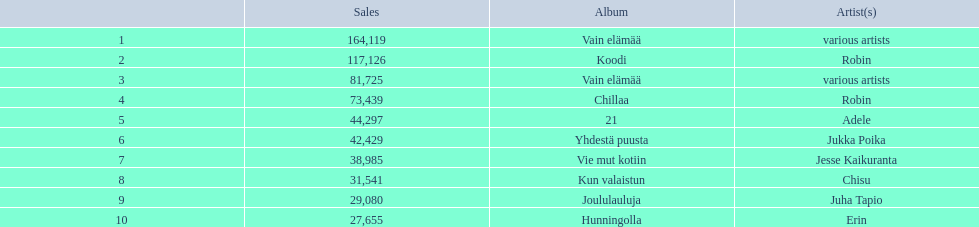Can you give me this table in json format? {'header': ['', 'Sales', 'Album', 'Artist(s)'], 'rows': [['1', '164,119', 'Vain elämää', 'various artists'], ['2', '117,126', 'Koodi', 'Robin'], ['3', '81,725', 'Vain elämää', 'various artists'], ['4', '73,439', 'Chillaa', 'Robin'], ['5', '44,297', '21', 'Adele'], ['6', '42,429', 'Yhdestä puusta', 'Jukka Poika'], ['7', '38,985', 'Vie mut kotiin', 'Jesse Kaikuranta'], ['8', '31,541', 'Kun valaistun', 'Chisu'], ['9', '29,080', 'Joululauluja', 'Juha Tapio'], ['10', '27,655', 'Hunningolla', 'Erin']]} Which were the number-one albums of 2012 in finland? Vain elämää, Koodi, Vain elämää, Chillaa, 21, Yhdestä puusta, Vie mut kotiin, Kun valaistun, Joululauluja, Hunningolla. Of those albums, which were by robin? Koodi, Chillaa. Of those albums by robin, which is not chillaa? Koodi. 